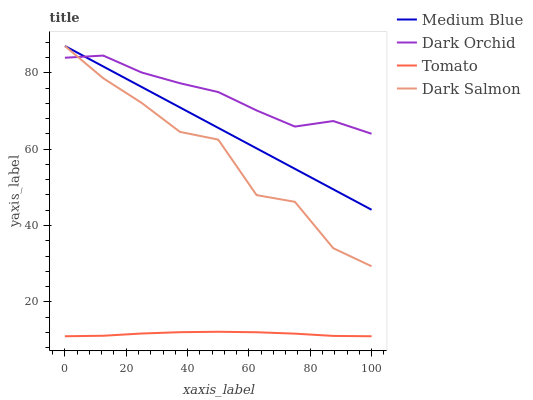Does Tomato have the minimum area under the curve?
Answer yes or no. Yes. Does Dark Orchid have the maximum area under the curve?
Answer yes or no. Yes. Does Medium Blue have the minimum area under the curve?
Answer yes or no. No. Does Medium Blue have the maximum area under the curve?
Answer yes or no. No. Is Medium Blue the smoothest?
Answer yes or no. Yes. Is Dark Salmon the roughest?
Answer yes or no. Yes. Is Dark Salmon the smoothest?
Answer yes or no. No. Is Medium Blue the roughest?
Answer yes or no. No. Does Tomato have the lowest value?
Answer yes or no. Yes. Does Medium Blue have the lowest value?
Answer yes or no. No. Does Dark Salmon have the highest value?
Answer yes or no. Yes. Does Dark Orchid have the highest value?
Answer yes or no. No. Is Tomato less than Medium Blue?
Answer yes or no. Yes. Is Dark Salmon greater than Tomato?
Answer yes or no. Yes. Does Dark Orchid intersect Dark Salmon?
Answer yes or no. Yes. Is Dark Orchid less than Dark Salmon?
Answer yes or no. No. Is Dark Orchid greater than Dark Salmon?
Answer yes or no. No. Does Tomato intersect Medium Blue?
Answer yes or no. No. 